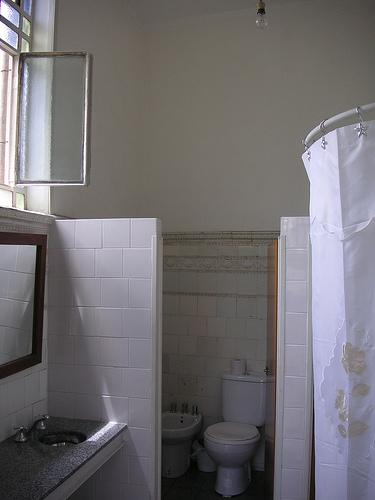Provide a brief description of the primary objects and their placement in the image. There is a light on the ceiling, walls with tiles, a mirror, an open window, a white shower curtain, a white toilet, a bathroom sink, and a glass pane window with iron trim. Can you identify the type of flowers on the shower curtain, based on the description in the image? The flowers on the shower curtain are white roses. What type of room is depicted in the image? The image depicts a bathroom. In the given image data, from what object is sunlight coming? Sunlight is shining from a window high in the bathroom wall. Enumerate the objects seen on or around the toilet seat. White toilet bowl, toilet seat cover, bidet, toilet paper roll, and toilet water tank. How many mirrors are in the bathroom, and are there any specific features mentioned about them? There is one mirror in the bathroom with brown wooden trim. Mention the color of tiles mentioned in three different image based on text descriptions. The tiles on the divider, wall, and floor are all white. What is the main source of light indicated in the image details, and where is it located? The main source of light is a light bulb, located on the ceiling. Based on the image details, what kind of curtain rod is present in the bathroom? There is a curved shower rod present. Describe the design of the shower hooks mentioned in the image. The design of the shower hooks is silver stars. Identify any anomalies or unusual features in this bathroom image. There are none, as the bathroom seems well-maintained and clean. Is there a wooden frame around the glass pane window? The image captions talk about a glass pane window with iron trim, not a wooden frame. Describe the interaction between the toilet paper roll and the toilet in this image. The toilet paper roll is placed on the back of the toilet. What material are the tiles on the divider made of? White ceramic. Please locate the position and dimensions of the light on the ceiling in the picture. X:245 Y:6 Width:34 Height:34 Find the position of the light bulb hanging from the ceiling in the image. X:244 Y:0 Width:29 Height:29 Find the position of the faucet on the bathroom sink in the image. X:18 Y:409 Width:31 Height:31 What is the overall quality of the image in terms of objects and their details? The image quality is good with clear and identifiable objects. Describe the overall sentiment of the bathroom scene in the image. Clean and well-maintained. What kind of light fixture is illuminating the bathroom in this image? A light bulb hanging from the ceiling. List the text of the captured captions displayed in the photo. There's no visible text in the given image details. Do you see a large bathtub in the corner of the bathroom? None of the captions mention a bathtub in the bathroom, so this object is not described in the image. Based on the image, please describe the predominant emotions or moods. Calm, serene, and orderly. Identify any surface where the sun might be shining in the bathroom. The sun shining on the wall. Can you notice the carpeted floor in the bathroom? The image captions mention that the floor is tiled, not carpeted. Is there a yellow light bulb attached to the wall near the mirror? The image captions mention a light bulb hanging from the ceiling, not attached to the wall near the mirror. Moreover, the bulb is not specified to be yellow. Count the total number of objects related to the white toilet in this image. 6 objects (toilet bowl, seat cover, toilet paper roll, toilet with bidet, toilet paper on the toilet, white toilet) Determine whether the surface of the floor in the image appears to be clean or dirty. The floor appears to be clean. What can you find in the upper left corner of the image? A window high in a bathroom wall. Identify the colors and textures present in the image. White, brown, silver, tiled, wooden, iron, and glass. Is that a red shower curtain with a blue design? The image caption mentions the shower curtain is white with a white rose design, not red with a blue design. Which objects are interacting with the white shower curtain in the image? Silver star shower hook and curved shower rod. Which object is nearest to the bathroom sink? The water faucet fixtures. Is the water faucet on or off in the bathroom sink? The faucet appears to be off in the image. Can you spot the green mosaic tiles on the divider? The image captions indicate white tiles on the divider, not green mosaic tiles. How many objects in the image are related to shower curtains? 4 objects (the white shower curtain, stained shower curtain, design on the curtain, white rose-decorated shower curtain) 